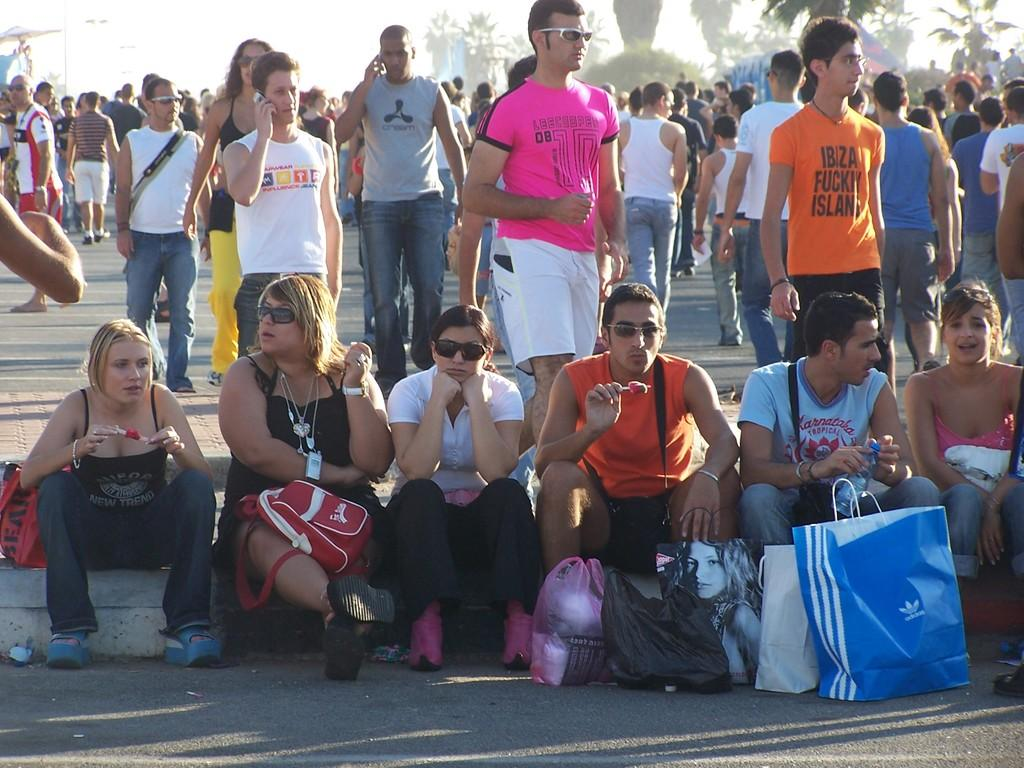<image>
Describe the image concisely. A crowd of people, with one man in an orange shirt that says Ibiza Fuckily Island. 